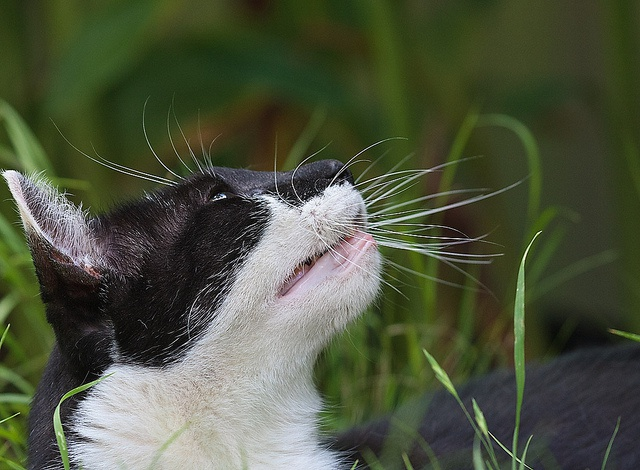Describe the objects in this image and their specific colors. I can see a cat in darkgreen, black, darkgray, lightgray, and gray tones in this image. 